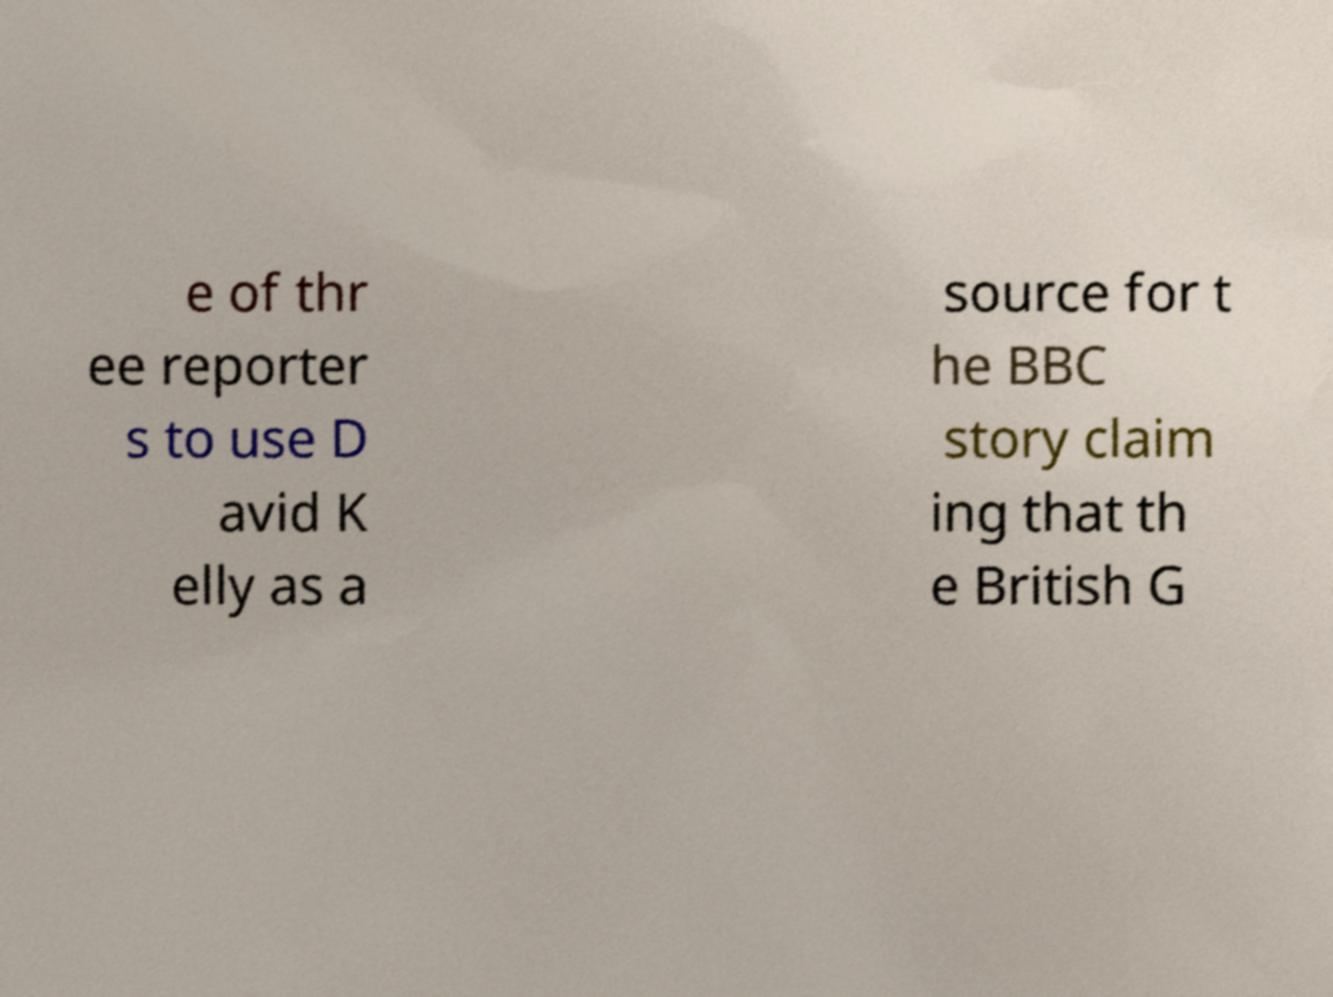Could you assist in decoding the text presented in this image and type it out clearly? e of thr ee reporter s to use D avid K elly as a source for t he BBC story claim ing that th e British G 